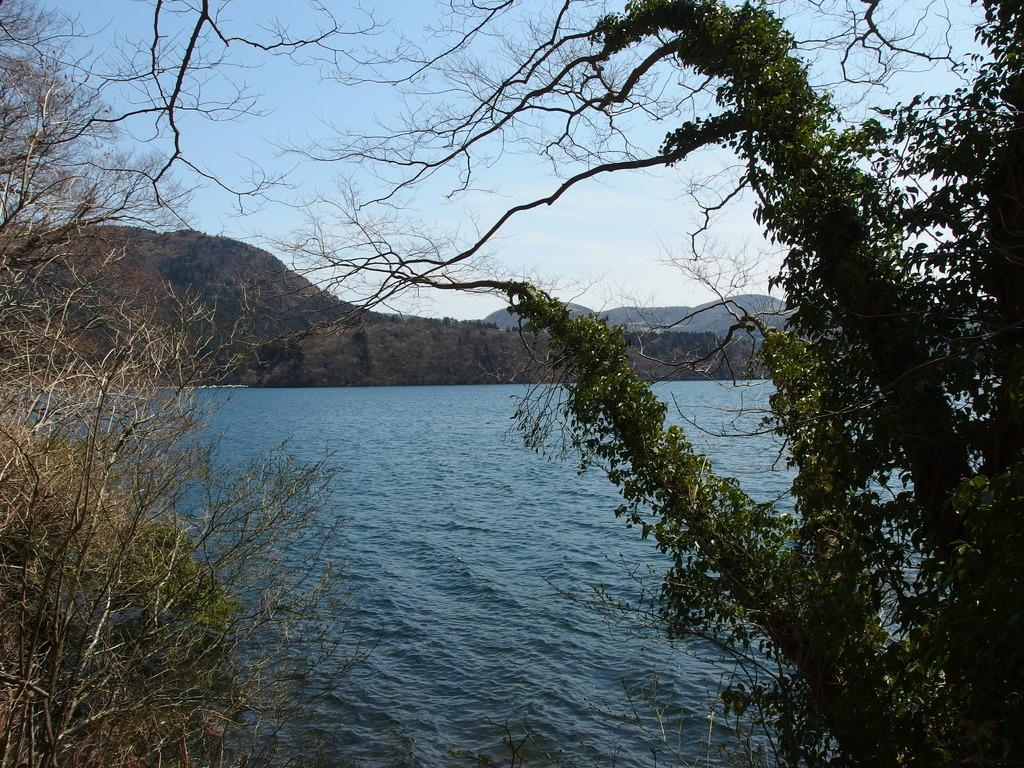What is the main subject in the center of the image? There is water in the center of the image. What can be seen in the background of the image? There are trees and mountains in the background of the image. What else is visible in the background of the image? The sky is visible in the background of the image. Can you hear the argument between the birds in the image? There are no birds present in the image, so it is not possible to hear any argument between them. 